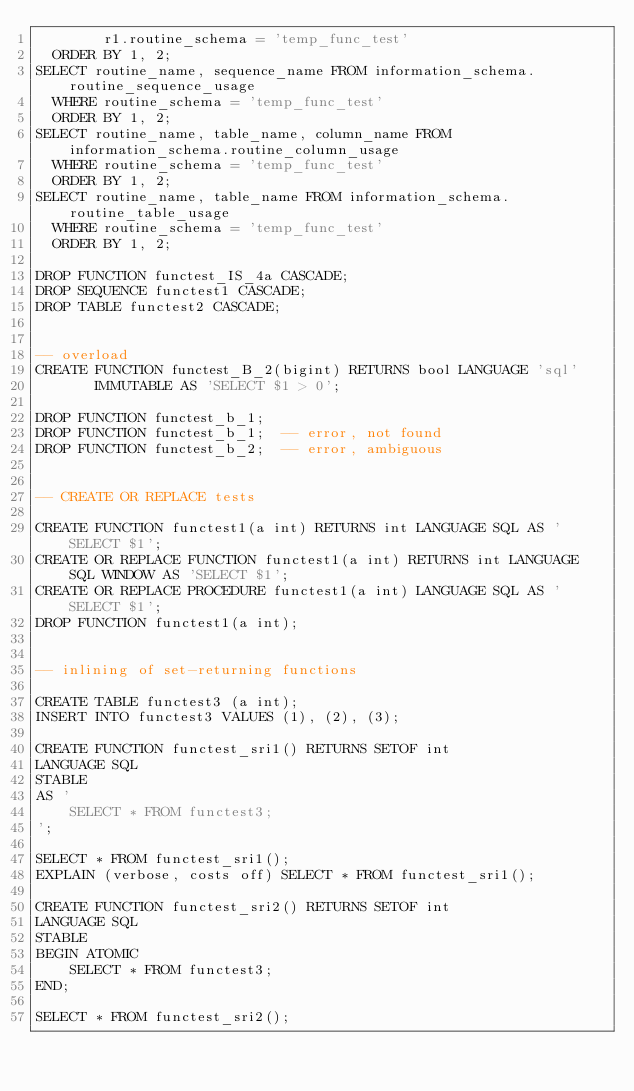<code> <loc_0><loc_0><loc_500><loc_500><_SQL_>        r1.routine_schema = 'temp_func_test'
  ORDER BY 1, 2;
SELECT routine_name, sequence_name FROM information_schema.routine_sequence_usage
  WHERE routine_schema = 'temp_func_test'
  ORDER BY 1, 2;
SELECT routine_name, table_name, column_name FROM information_schema.routine_column_usage
  WHERE routine_schema = 'temp_func_test'
  ORDER BY 1, 2;
SELECT routine_name, table_name FROM information_schema.routine_table_usage
  WHERE routine_schema = 'temp_func_test'
  ORDER BY 1, 2;

DROP FUNCTION functest_IS_4a CASCADE;
DROP SEQUENCE functest1 CASCADE;
DROP TABLE functest2 CASCADE;


-- overload
CREATE FUNCTION functest_B_2(bigint) RETURNS bool LANGUAGE 'sql'
       IMMUTABLE AS 'SELECT $1 > 0';

DROP FUNCTION functest_b_1;
DROP FUNCTION functest_b_1;  -- error, not found
DROP FUNCTION functest_b_2;  -- error, ambiguous


-- CREATE OR REPLACE tests

CREATE FUNCTION functest1(a int) RETURNS int LANGUAGE SQL AS 'SELECT $1';
CREATE OR REPLACE FUNCTION functest1(a int) RETURNS int LANGUAGE SQL WINDOW AS 'SELECT $1';
CREATE OR REPLACE PROCEDURE functest1(a int) LANGUAGE SQL AS 'SELECT $1';
DROP FUNCTION functest1(a int);


-- inlining of set-returning functions

CREATE TABLE functest3 (a int);
INSERT INTO functest3 VALUES (1), (2), (3);

CREATE FUNCTION functest_sri1() RETURNS SETOF int
LANGUAGE SQL
STABLE
AS '
    SELECT * FROM functest3;
';

SELECT * FROM functest_sri1();
EXPLAIN (verbose, costs off) SELECT * FROM functest_sri1();

CREATE FUNCTION functest_sri2() RETURNS SETOF int
LANGUAGE SQL
STABLE
BEGIN ATOMIC
    SELECT * FROM functest3;
END;

SELECT * FROM functest_sri2();</code> 